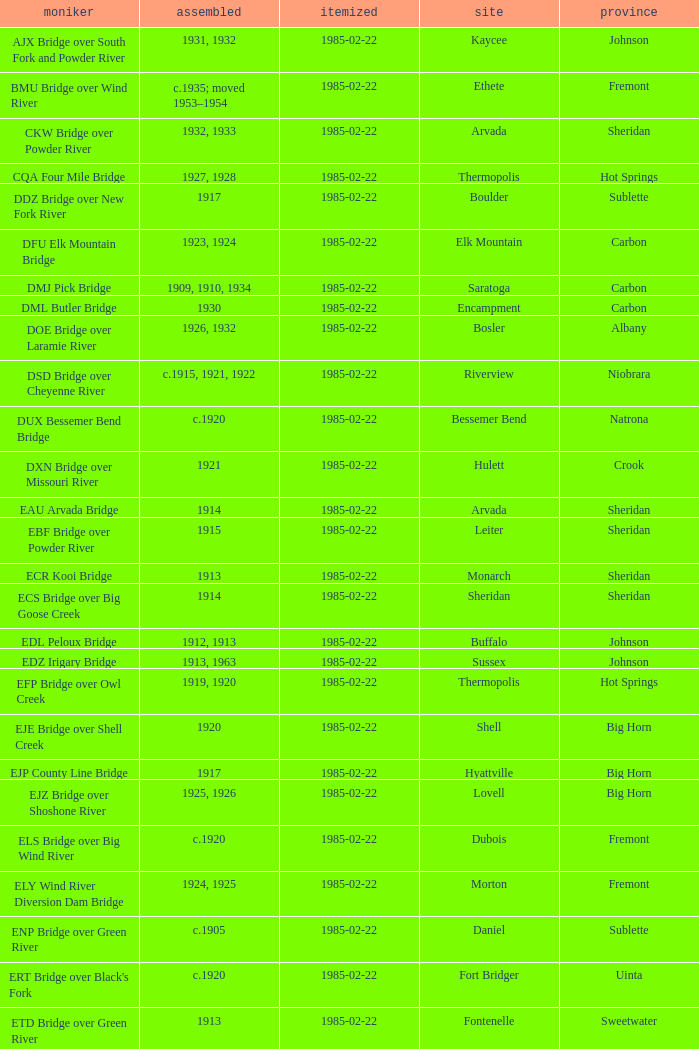What is the county of the bridge in Boulder? Sublette. 